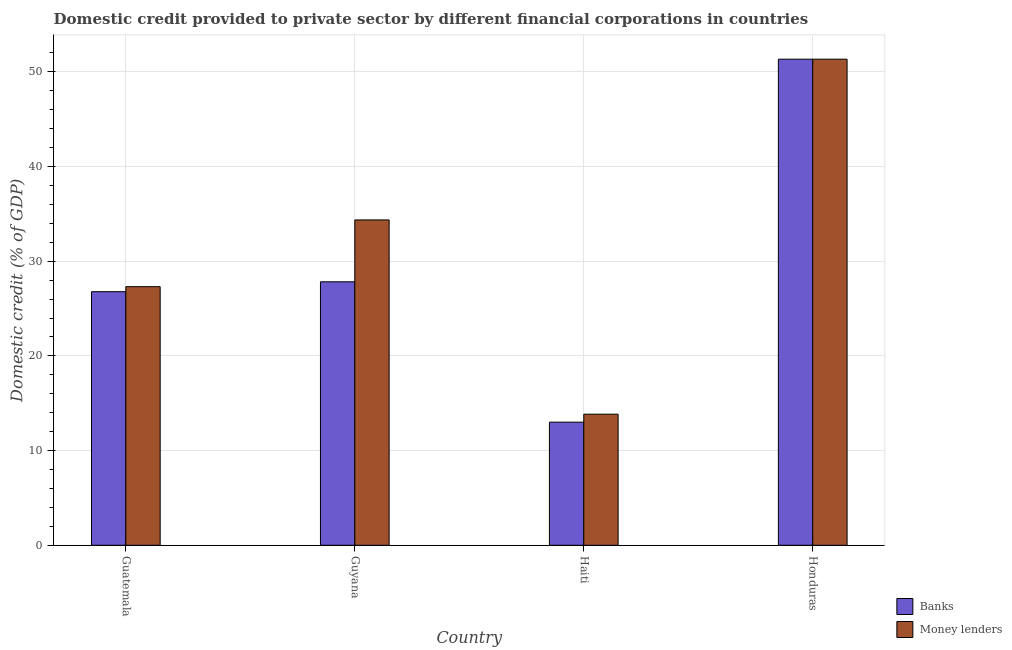Are the number of bars per tick equal to the number of legend labels?
Provide a short and direct response. Yes. Are the number of bars on each tick of the X-axis equal?
Offer a terse response. Yes. How many bars are there on the 4th tick from the right?
Provide a short and direct response. 2. What is the label of the 2nd group of bars from the left?
Give a very brief answer. Guyana. What is the domestic credit provided by money lenders in Guyana?
Make the answer very short. 34.36. Across all countries, what is the maximum domestic credit provided by money lenders?
Keep it short and to the point. 51.34. Across all countries, what is the minimum domestic credit provided by banks?
Your answer should be compact. 13. In which country was the domestic credit provided by money lenders maximum?
Provide a succinct answer. Honduras. In which country was the domestic credit provided by money lenders minimum?
Give a very brief answer. Haiti. What is the total domestic credit provided by banks in the graph?
Give a very brief answer. 118.96. What is the difference between the domestic credit provided by money lenders in Guatemala and that in Guyana?
Provide a succinct answer. -7.05. What is the difference between the domestic credit provided by money lenders in Haiti and the domestic credit provided by banks in Honduras?
Provide a short and direct response. -37.5. What is the average domestic credit provided by banks per country?
Offer a terse response. 29.74. What is the difference between the domestic credit provided by money lenders and domestic credit provided by banks in Guyana?
Provide a succinct answer. 6.54. In how many countries, is the domestic credit provided by banks greater than 20 %?
Provide a short and direct response. 3. What is the ratio of the domestic credit provided by money lenders in Guyana to that in Honduras?
Provide a short and direct response. 0.67. Is the domestic credit provided by money lenders in Haiti less than that in Honduras?
Your answer should be compact. Yes. What is the difference between the highest and the second highest domestic credit provided by banks?
Your answer should be compact. 23.51. What is the difference between the highest and the lowest domestic credit provided by banks?
Your answer should be compact. 38.34. In how many countries, is the domestic credit provided by banks greater than the average domestic credit provided by banks taken over all countries?
Your answer should be compact. 1. What does the 2nd bar from the left in Guatemala represents?
Make the answer very short. Money lenders. What does the 1st bar from the right in Guatemala represents?
Provide a succinct answer. Money lenders. How many bars are there?
Make the answer very short. 8. How many countries are there in the graph?
Provide a short and direct response. 4. Does the graph contain grids?
Make the answer very short. Yes. How many legend labels are there?
Offer a terse response. 2. How are the legend labels stacked?
Your response must be concise. Vertical. What is the title of the graph?
Offer a very short reply. Domestic credit provided to private sector by different financial corporations in countries. What is the label or title of the Y-axis?
Keep it short and to the point. Domestic credit (% of GDP). What is the Domestic credit (% of GDP) of Banks in Guatemala?
Keep it short and to the point. 26.78. What is the Domestic credit (% of GDP) in Money lenders in Guatemala?
Ensure brevity in your answer.  27.31. What is the Domestic credit (% of GDP) of Banks in Guyana?
Your response must be concise. 27.83. What is the Domestic credit (% of GDP) of Money lenders in Guyana?
Provide a short and direct response. 34.36. What is the Domestic credit (% of GDP) of Banks in Haiti?
Make the answer very short. 13. What is the Domestic credit (% of GDP) of Money lenders in Haiti?
Offer a very short reply. 13.85. What is the Domestic credit (% of GDP) of Banks in Honduras?
Your response must be concise. 51.34. What is the Domestic credit (% of GDP) in Money lenders in Honduras?
Provide a succinct answer. 51.34. Across all countries, what is the maximum Domestic credit (% of GDP) in Banks?
Keep it short and to the point. 51.34. Across all countries, what is the maximum Domestic credit (% of GDP) in Money lenders?
Your response must be concise. 51.34. Across all countries, what is the minimum Domestic credit (% of GDP) of Banks?
Your response must be concise. 13. Across all countries, what is the minimum Domestic credit (% of GDP) of Money lenders?
Make the answer very short. 13.85. What is the total Domestic credit (% of GDP) of Banks in the graph?
Provide a succinct answer. 118.96. What is the total Domestic credit (% of GDP) of Money lenders in the graph?
Make the answer very short. 126.87. What is the difference between the Domestic credit (% of GDP) of Banks in Guatemala and that in Guyana?
Offer a terse response. -1.04. What is the difference between the Domestic credit (% of GDP) of Money lenders in Guatemala and that in Guyana?
Offer a terse response. -7.05. What is the difference between the Domestic credit (% of GDP) in Banks in Guatemala and that in Haiti?
Provide a short and direct response. 13.78. What is the difference between the Domestic credit (% of GDP) of Money lenders in Guatemala and that in Haiti?
Offer a terse response. 13.47. What is the difference between the Domestic credit (% of GDP) of Banks in Guatemala and that in Honduras?
Your answer should be compact. -24.56. What is the difference between the Domestic credit (% of GDP) of Money lenders in Guatemala and that in Honduras?
Make the answer very short. -24.03. What is the difference between the Domestic credit (% of GDP) in Banks in Guyana and that in Haiti?
Provide a succinct answer. 14.83. What is the difference between the Domestic credit (% of GDP) of Money lenders in Guyana and that in Haiti?
Your answer should be very brief. 20.52. What is the difference between the Domestic credit (% of GDP) of Banks in Guyana and that in Honduras?
Ensure brevity in your answer.  -23.51. What is the difference between the Domestic credit (% of GDP) in Money lenders in Guyana and that in Honduras?
Provide a succinct answer. -16.98. What is the difference between the Domestic credit (% of GDP) in Banks in Haiti and that in Honduras?
Give a very brief answer. -38.34. What is the difference between the Domestic credit (% of GDP) of Money lenders in Haiti and that in Honduras?
Provide a short and direct response. -37.5. What is the difference between the Domestic credit (% of GDP) in Banks in Guatemala and the Domestic credit (% of GDP) in Money lenders in Guyana?
Ensure brevity in your answer.  -7.58. What is the difference between the Domestic credit (% of GDP) in Banks in Guatemala and the Domestic credit (% of GDP) in Money lenders in Haiti?
Your answer should be compact. 12.94. What is the difference between the Domestic credit (% of GDP) of Banks in Guatemala and the Domestic credit (% of GDP) of Money lenders in Honduras?
Ensure brevity in your answer.  -24.56. What is the difference between the Domestic credit (% of GDP) in Banks in Guyana and the Domestic credit (% of GDP) in Money lenders in Haiti?
Keep it short and to the point. 13.98. What is the difference between the Domestic credit (% of GDP) in Banks in Guyana and the Domestic credit (% of GDP) in Money lenders in Honduras?
Make the answer very short. -23.51. What is the difference between the Domestic credit (% of GDP) of Banks in Haiti and the Domestic credit (% of GDP) of Money lenders in Honduras?
Your answer should be very brief. -38.34. What is the average Domestic credit (% of GDP) in Banks per country?
Offer a very short reply. 29.74. What is the average Domestic credit (% of GDP) of Money lenders per country?
Ensure brevity in your answer.  31.72. What is the difference between the Domestic credit (% of GDP) of Banks and Domestic credit (% of GDP) of Money lenders in Guatemala?
Make the answer very short. -0.53. What is the difference between the Domestic credit (% of GDP) in Banks and Domestic credit (% of GDP) in Money lenders in Guyana?
Offer a very short reply. -6.54. What is the difference between the Domestic credit (% of GDP) of Banks and Domestic credit (% of GDP) of Money lenders in Haiti?
Make the answer very short. -0.84. What is the difference between the Domestic credit (% of GDP) in Banks and Domestic credit (% of GDP) in Money lenders in Honduras?
Make the answer very short. 0. What is the ratio of the Domestic credit (% of GDP) in Banks in Guatemala to that in Guyana?
Give a very brief answer. 0.96. What is the ratio of the Domestic credit (% of GDP) of Money lenders in Guatemala to that in Guyana?
Your response must be concise. 0.79. What is the ratio of the Domestic credit (% of GDP) of Banks in Guatemala to that in Haiti?
Your response must be concise. 2.06. What is the ratio of the Domestic credit (% of GDP) in Money lenders in Guatemala to that in Haiti?
Ensure brevity in your answer.  1.97. What is the ratio of the Domestic credit (% of GDP) of Banks in Guatemala to that in Honduras?
Make the answer very short. 0.52. What is the ratio of the Domestic credit (% of GDP) in Money lenders in Guatemala to that in Honduras?
Your answer should be very brief. 0.53. What is the ratio of the Domestic credit (% of GDP) of Banks in Guyana to that in Haiti?
Your answer should be compact. 2.14. What is the ratio of the Domestic credit (% of GDP) in Money lenders in Guyana to that in Haiti?
Your answer should be compact. 2.48. What is the ratio of the Domestic credit (% of GDP) of Banks in Guyana to that in Honduras?
Make the answer very short. 0.54. What is the ratio of the Domestic credit (% of GDP) of Money lenders in Guyana to that in Honduras?
Keep it short and to the point. 0.67. What is the ratio of the Domestic credit (% of GDP) in Banks in Haiti to that in Honduras?
Offer a very short reply. 0.25. What is the ratio of the Domestic credit (% of GDP) in Money lenders in Haiti to that in Honduras?
Your answer should be compact. 0.27. What is the difference between the highest and the second highest Domestic credit (% of GDP) in Banks?
Offer a terse response. 23.51. What is the difference between the highest and the second highest Domestic credit (% of GDP) of Money lenders?
Make the answer very short. 16.98. What is the difference between the highest and the lowest Domestic credit (% of GDP) of Banks?
Offer a very short reply. 38.34. What is the difference between the highest and the lowest Domestic credit (% of GDP) in Money lenders?
Keep it short and to the point. 37.5. 